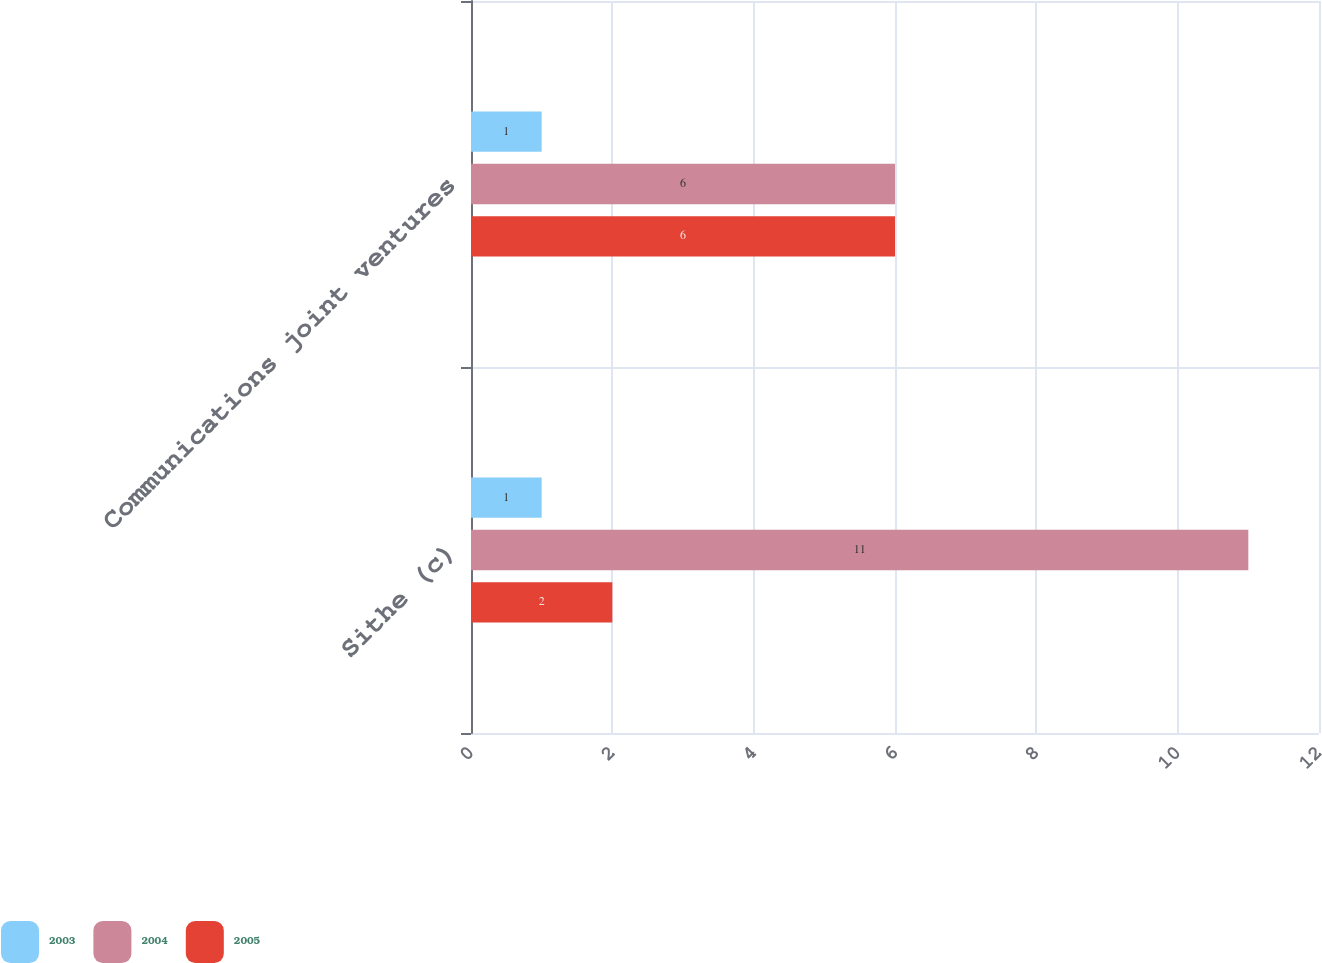<chart> <loc_0><loc_0><loc_500><loc_500><stacked_bar_chart><ecel><fcel>Sithe (c)<fcel>Communications joint ventures<nl><fcel>2003<fcel>1<fcel>1<nl><fcel>2004<fcel>11<fcel>6<nl><fcel>2005<fcel>2<fcel>6<nl></chart> 